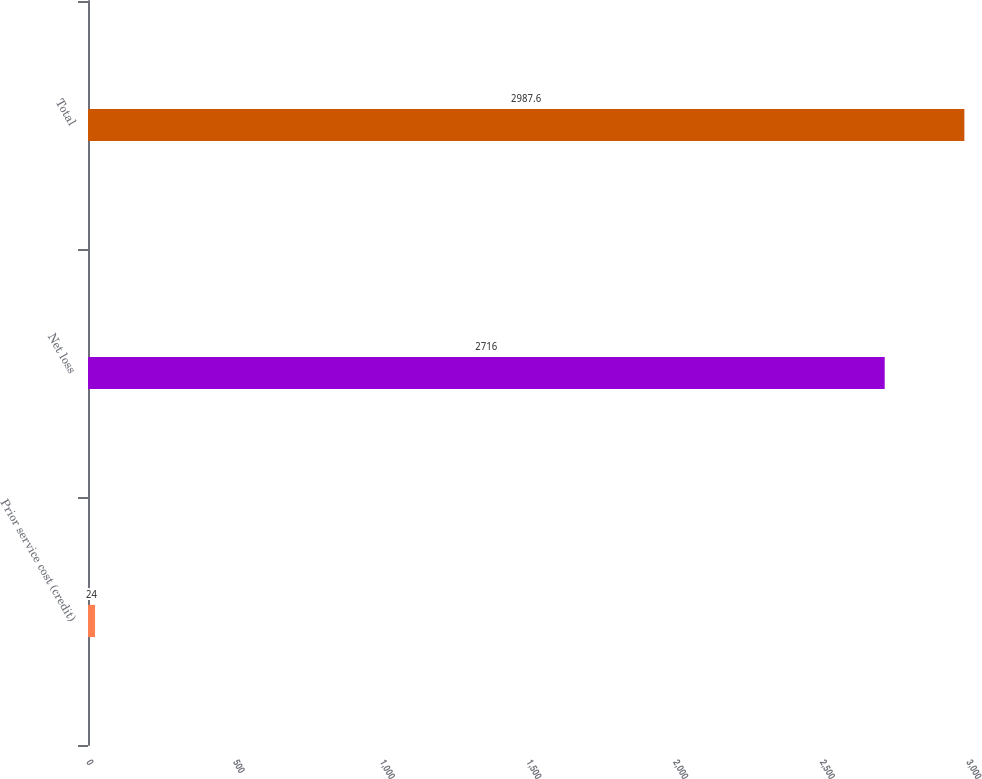Convert chart. <chart><loc_0><loc_0><loc_500><loc_500><bar_chart><fcel>Prior service cost (credit)<fcel>Net loss<fcel>Total<nl><fcel>24<fcel>2716<fcel>2987.6<nl></chart> 